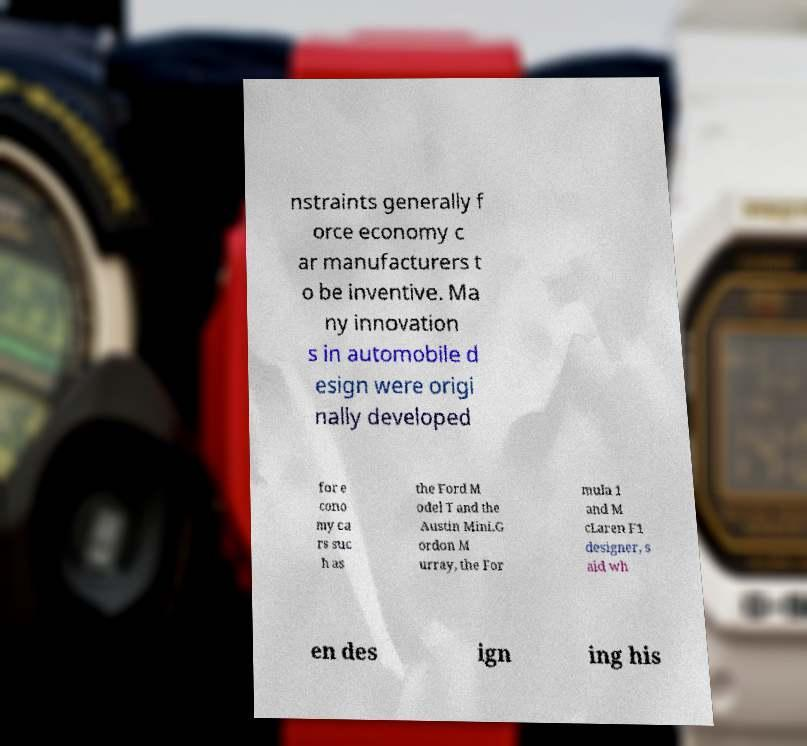Can you read and provide the text displayed in the image?This photo seems to have some interesting text. Can you extract and type it out for me? nstraints generally f orce economy c ar manufacturers t o be inventive. Ma ny innovation s in automobile d esign were origi nally developed for e cono my ca rs suc h as the Ford M odel T and the Austin Mini.G ordon M urray, the For mula 1 and M cLaren F1 designer, s aid wh en des ign ing his 